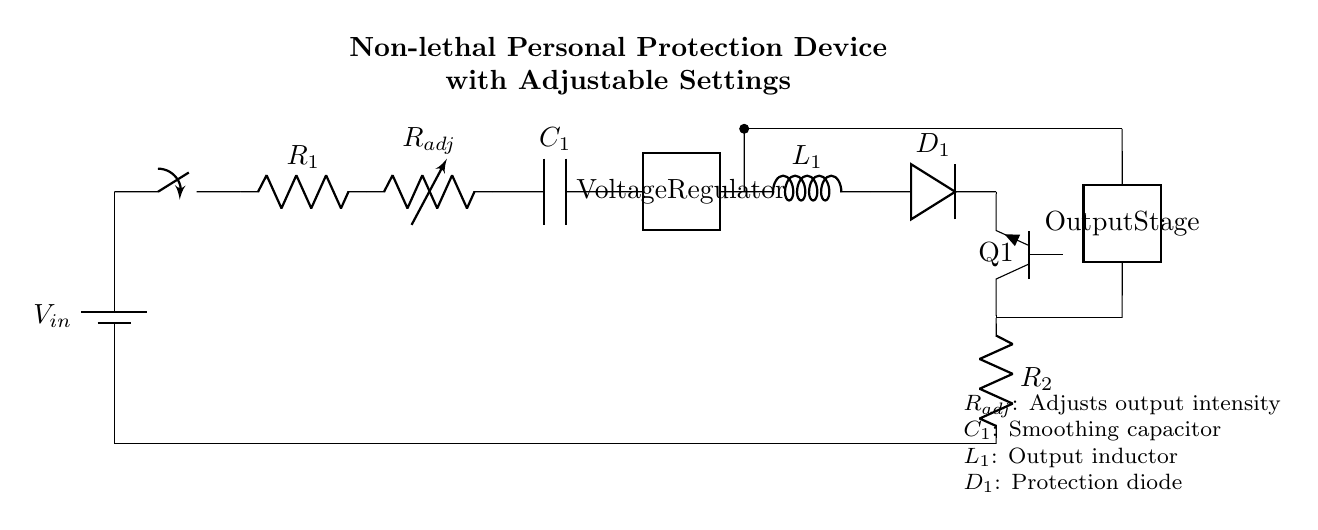What is the type of the adjustable resistor in the circuit? The circuit includes a variable resistor labeled as "R_adj," indicating it can be adjusted.
Answer: variable resistor What is the purpose of the capacitor C1? The capacitor C1 is used for smoothing the output voltage, reducing fluctuations in the current.
Answer: smoothing What component regulates the voltage in this circuit? The voltage regulator is specifically marked as a two-port component in the diagram, indicating its function to maintain a stable output voltage.
Answer: Voltage Regulator How many resistors are in this circuit? There are two resistors mentioned: R1 and R2, as seen in the diagram.
Answer: two What effect does adjusting R_adj have on the device? Adjusting R_adj directly alters the output intensity of the personal protection device, impacting its effectiveness based on user preference or needs.
Answer: output intensity Which component provides protection from back EMF? The protection diode D1 prevents back EMF from affecting other components, a crucial function in maintaining circuit integrity.
Answer: protection diode What is the role of the inductor L1 in the circuit? The inductor L1 is used to filter the output signal, helping to smooth out current variations after the voltage regulation stage.
Answer: filtering 